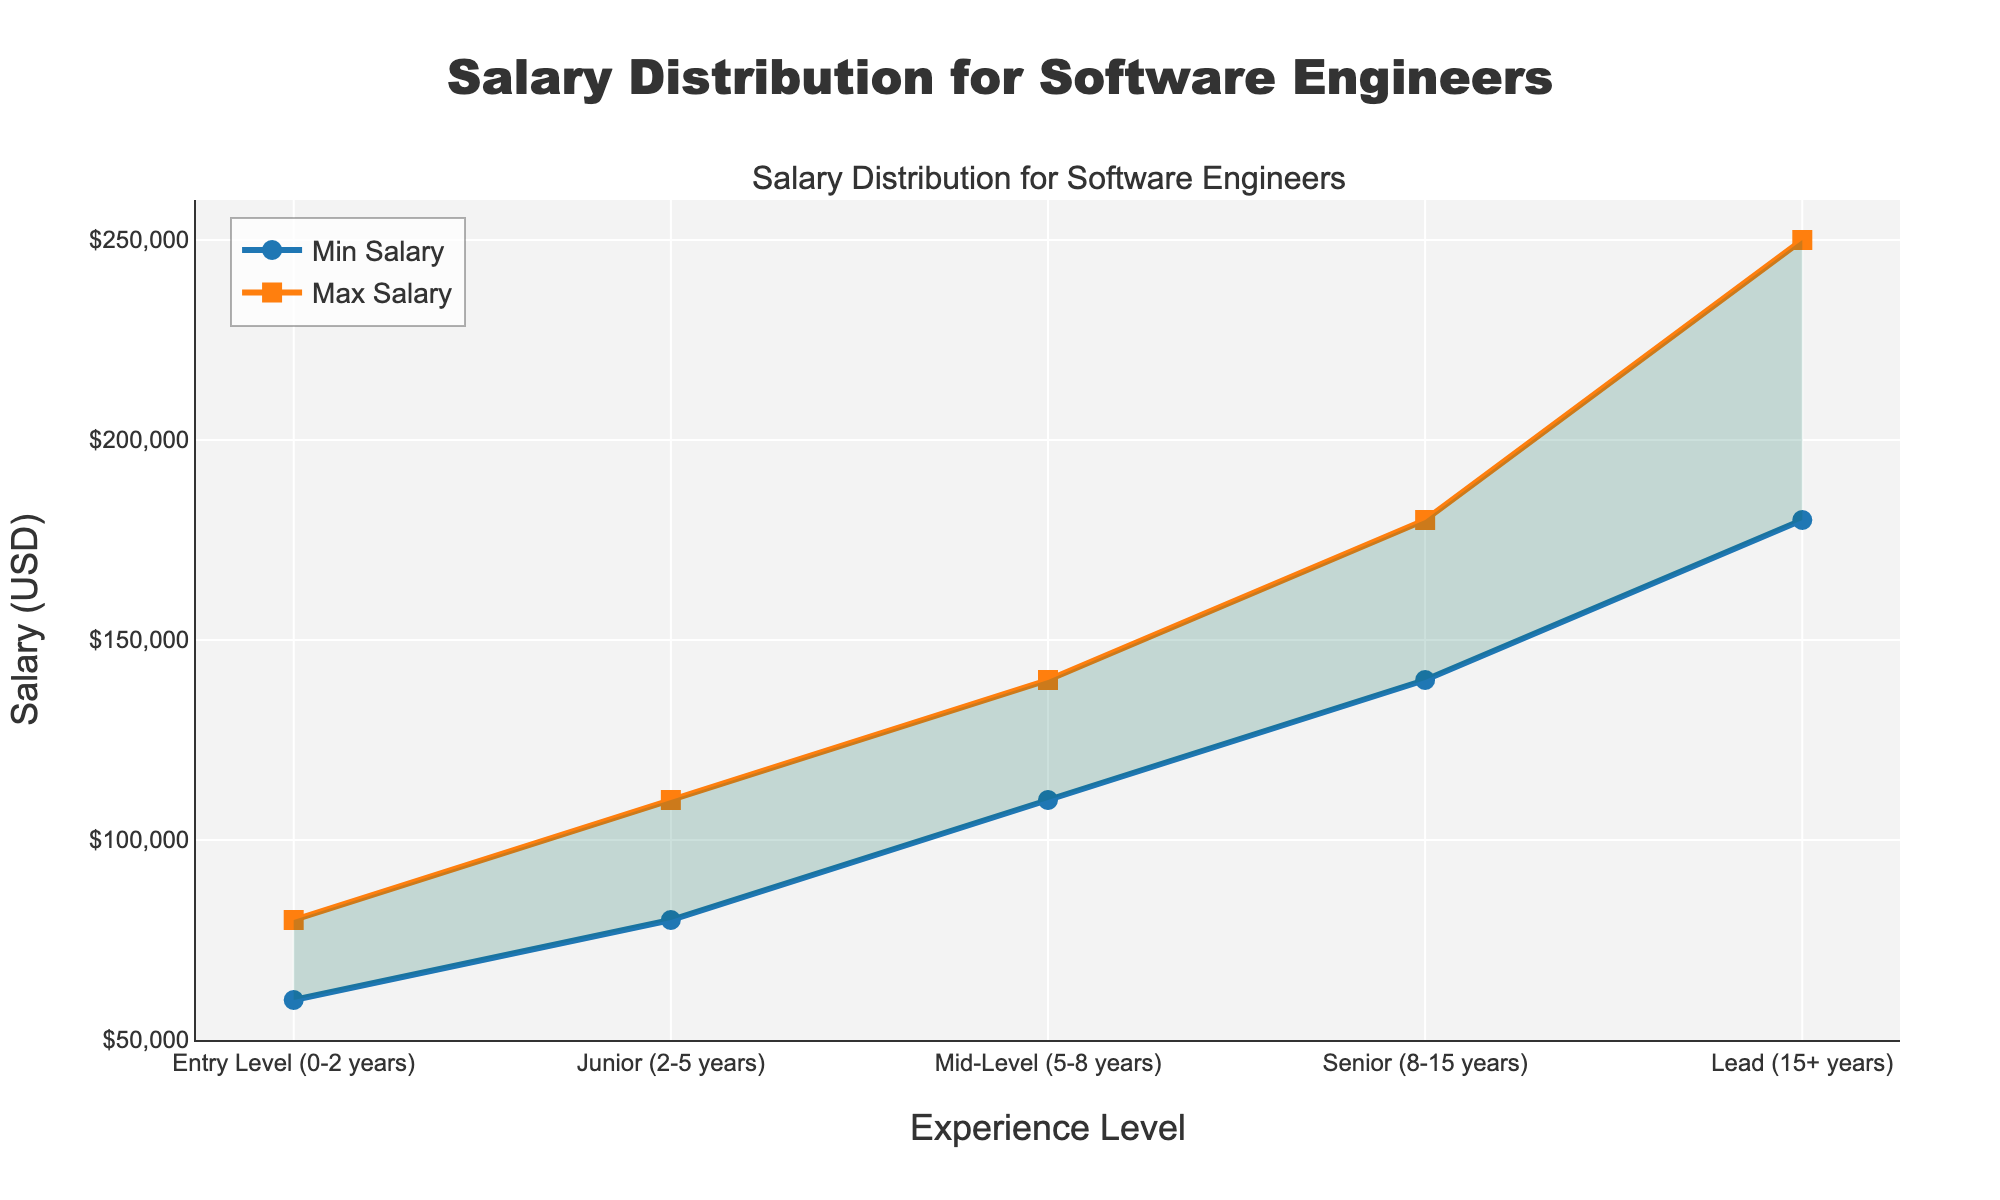Which experience level has the highest maximum salary? The highest maximum salary is represented by the "Lead (15+ years)" category, which has a maximum salary of $250,000 as shown at the end of the plot for that experience level.
Answer: Lead (15+ years) How does the minimum salary change from Entry Level to Senior level? The minimum salary increases as follows: Entry Level starts at $60,000, Junior increases to $80,000, Mid-Level increases to $110,000, and Senior increases to $140,000. In total, there is a progression from $60,000 to $140,000.
Answer: It increases from $60,000 to $140,000 What's the range of salary for Junior engineers? The range of salary for Junior engineers is calculated as the difference between the maximum and minimum salaries for that experience level. For Junior engineers, the maximum salary is $110,000 and the minimum salary is $80,000, giving a range of $110,000 - $80,000 = $30,000.
Answer: $30,000 Which experience level shows the most significant salary increase when moving from Mid-Level to Lead? By comparing the difference in maximum and minimum salaries between Mid-Level and Lead, we find that the minimum salary for Mid-Level is $110,000 and for Lead, it is $180,000. This is an increase of $70,000. The maximum salary for Mid-Level is $140,000 and for Lead, it is $250,000, an increase of $110,000. Both increases are significant, but the maximum salary increase is more substantial.
Answer: Lead What is the title of the plot? The title of the plot is found at the top center and reads "Salary Distribution for Software Engineers".
Answer: Salary Distribution for Software Engineers At which experience level does the maximum salary first exceed $200,000? Looking at the plot, the first experience level where the maximum salary exceeds $200,000 is the "Lead (15+ years)" level, where the maximum salary reaches $250,000.
Answer: Lead (15+ years) What is the color used to denote the area between minimum and maximum salaries? The area between the minimum and maximum salaries is shaded with a transparent green color, as it is intended to show the distribution range.
Answer: Transparent green What is the minimum salary for Mid-Level engineers? The minimum salary for Mid-Level engineers is shown on the plot as the point where the minimum salary line reaches the "Mid-Level (5-8 years)" category, which is $110,000.
Answer: $110,000 